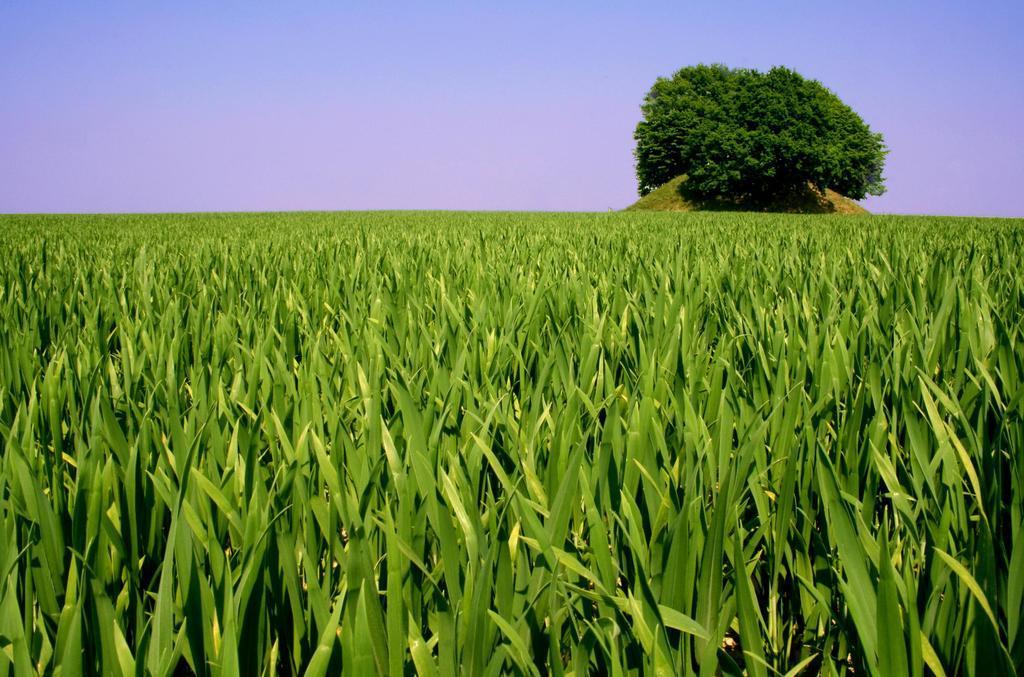Describe this image in one or two sentences. In the background we can see the sky, tree. This picture is mainly highlighted with the field and its full of greenery. 